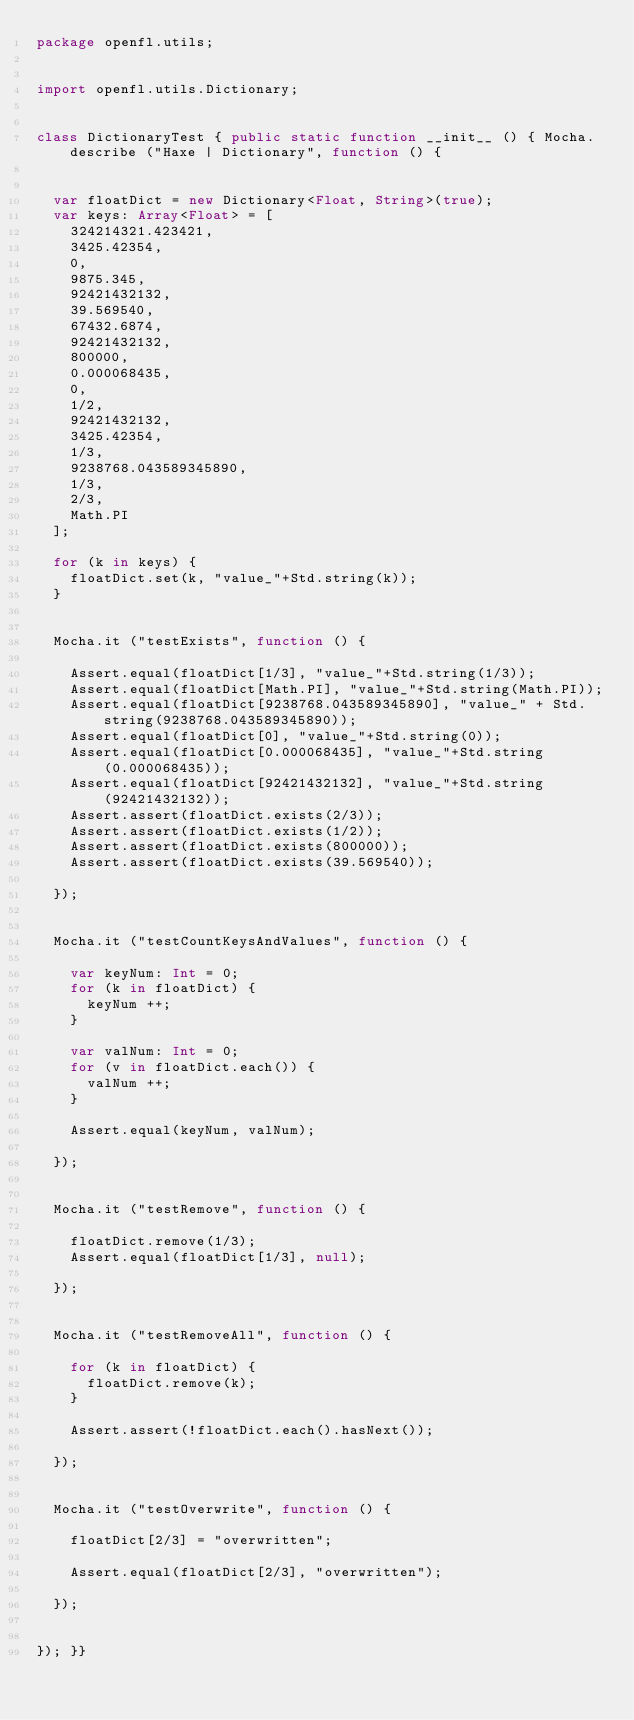Convert code to text. <code><loc_0><loc_0><loc_500><loc_500><_Haxe_>package openfl.utils;


import openfl.utils.Dictionary;


class DictionaryTest { public static function __init__ () { Mocha.describe ("Haxe | Dictionary", function () {
	
	
	var floatDict = new Dictionary<Float, String>(true);
	var keys: Array<Float> = [
		324214321.423421,
		3425.42354,
		0,
		9875.345,	
		92421432132,
		39.569540,
		67432.6874,
		92421432132,
		800000,
		0.000068435,
		0,
		1/2,
		92421432132,
		3425.42354,
		1/3,
		9238768.043589345890,
		1/3,
		2/3,
		Math.PI
	];
	
	for (k in keys) {
		floatDict.set(k, "value_"+Std.string(k));
	}
	
	
	Mocha.it ("testExists", function () {
		
		Assert.equal(floatDict[1/3], "value_"+Std.string(1/3));
		Assert.equal(floatDict[Math.PI], "value_"+Std.string(Math.PI));
		Assert.equal(floatDict[9238768.043589345890], "value_" + Std.string(9238768.043589345890));
		Assert.equal(floatDict[0], "value_"+Std.string(0));
		Assert.equal(floatDict[0.000068435], "value_"+Std.string(0.000068435));
		Assert.equal(floatDict[92421432132], "value_"+Std.string(92421432132));
		Assert.assert(floatDict.exists(2/3));
		Assert.assert(floatDict.exists(1/2));
		Assert.assert(floatDict.exists(800000));
		Assert.assert(floatDict.exists(39.569540));
		
	});
	
	
	Mocha.it ("testCountKeysAndValues", function () {
		
		var keyNum: Int = 0;
		for (k in floatDict) {
			keyNum ++;
		}
		
		var valNum: Int = 0;
		for (v in floatDict.each()) {
			valNum ++;
		}
		
		Assert.equal(keyNum, valNum);
		
	});
	
	
	Mocha.it ("testRemove", function () {
		
		floatDict.remove(1/3);
		Assert.equal(floatDict[1/3], null);
		
	});
	
	
	Mocha.it ("testRemoveAll", function () {
		
		for (k in floatDict) {
			floatDict.remove(k);
		}
		
		Assert.assert(!floatDict.each().hasNext());
		
	});
	
	
	Mocha.it ("testOverwrite", function () {
		
		floatDict[2/3] = "overwritten";
		
		Assert.equal(floatDict[2/3], "overwritten");
		
	});
	
	
}); }}</code> 